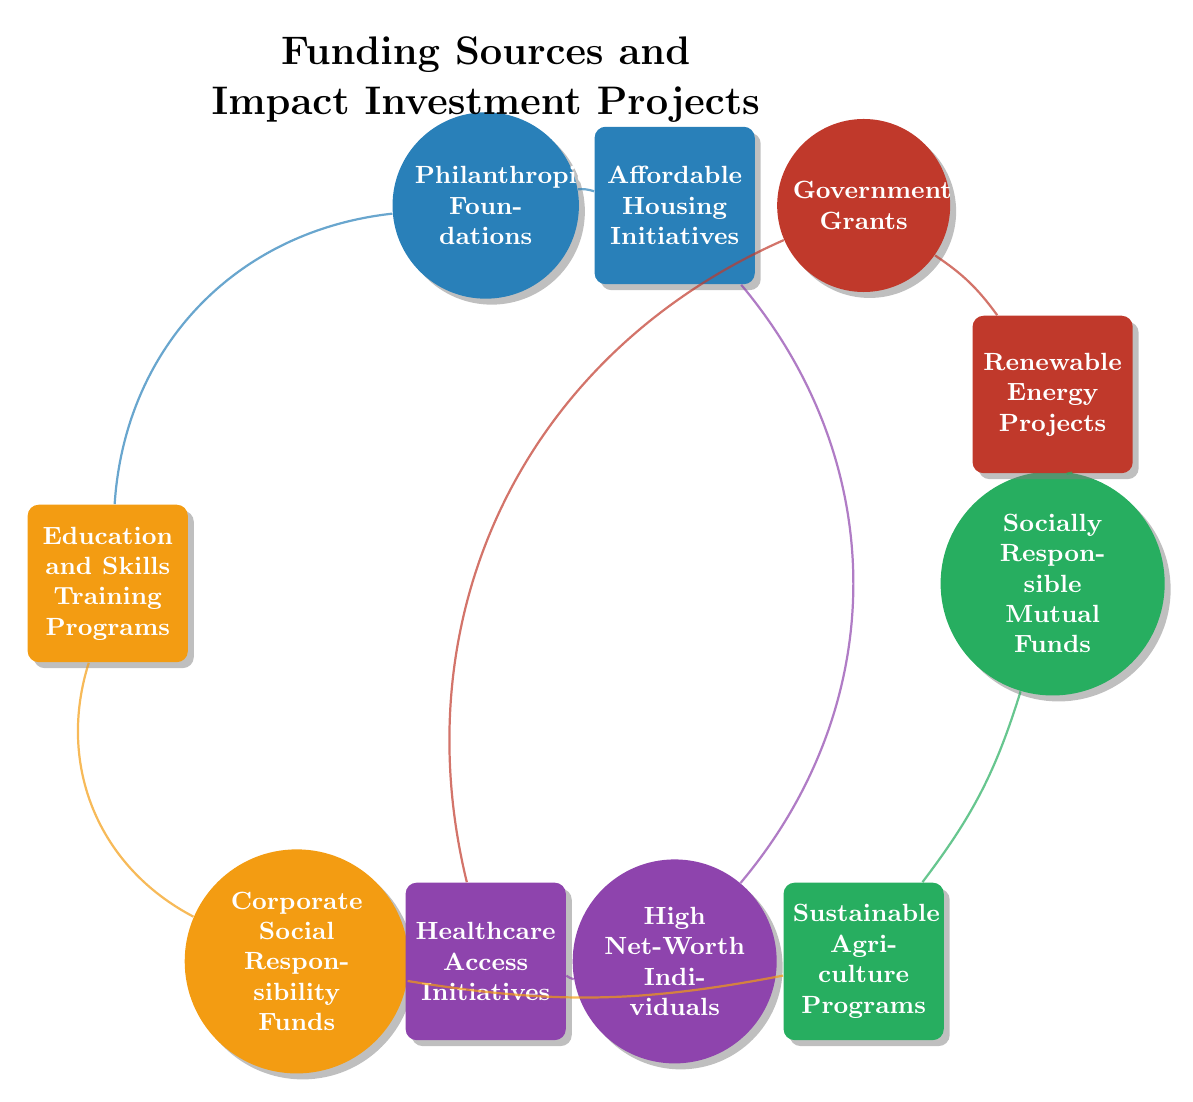What are the five funding sources shown in the diagram? The diagram lists five funding sources including: Philanthropic Foundations, Government Grants, Socially Responsible Mutual Funds, High Net-Worth Individuals, and Corporate Social Responsibility Funds.
Answer: Philanthropic Foundations, Government Grants, Socially Responsible Mutual Funds, High Net-Worth Individuals, Corporate Social Responsibility Funds Which impact investment project is supported by both Philanthropic Foundations and High Net-Worth Individuals? By examining the connections, Affordable Housing Initiatives is linked to both Philanthropic Foundations and High Net-Worth Individuals.
Answer: Affordable Housing Initiatives How many connections are there between funding sources and impact investment projects? Counting the lines drawn between nodes shows there are a total of 10 connections in the diagram.
Answer: 10 Which funding source is connected to the Renewable Energy Projects? The connections show that both Government Grants and Socially Responsible Mutual Funds are connected to Renewable Energy Projects.
Answer: Government Grants, Socially Responsible Mutual Funds Identify a project that is supported by Corporate Social Responsibility Funds. The connections indicate that Corporate Social Responsibility Funds supports Education and Skills Training Programs and Sustainable Agriculture Programs.
Answer: Education and Skills Training Programs, Sustainable Agriculture Programs How many impact investment projects are supported by Philanthropic Foundations? Analyzing the connections reveals that Philanthropic Foundations is connected to 2 projects: Affordable Housing Initiatives and Education and Skills Training Programs.
Answer: 2 Which funding source has the most connections to impact investment projects in the diagram? Counting the connections for each funding source, 4 connects to High Net-Worth Individuals, which is the highest number of connections, thus indicating it has the most links.
Answer: High Net-Worth Individuals Which project has the least support based on the funding sources? By reviewing the connections, Sustainable Agriculture Programs is supported by only 2 funding sources: Socially Responsible Mutual Funds and Corporate Social Responsibility Funds.
Answer: Sustainable Agriculture Programs What type of diagram is used to represent the relationships between funding sources and impact investment projects? The diagram type represented is a Chord Diagram, which visually illustrates relationships and connections between nodes.
Answer: Chord Diagram 